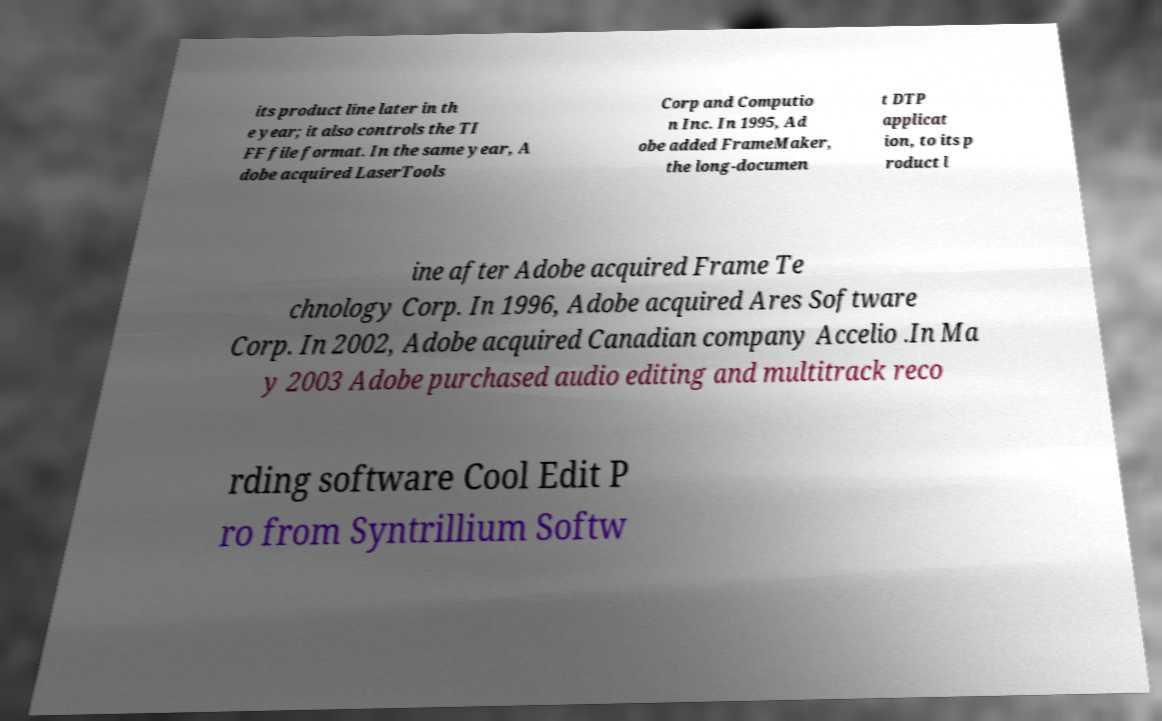What messages or text are displayed in this image? I need them in a readable, typed format. its product line later in th e year; it also controls the TI FF file format. In the same year, A dobe acquired LaserTools Corp and Computio n Inc. In 1995, Ad obe added FrameMaker, the long-documen t DTP applicat ion, to its p roduct l ine after Adobe acquired Frame Te chnology Corp. In 1996, Adobe acquired Ares Software Corp. In 2002, Adobe acquired Canadian company Accelio .In Ma y 2003 Adobe purchased audio editing and multitrack reco rding software Cool Edit P ro from Syntrillium Softw 